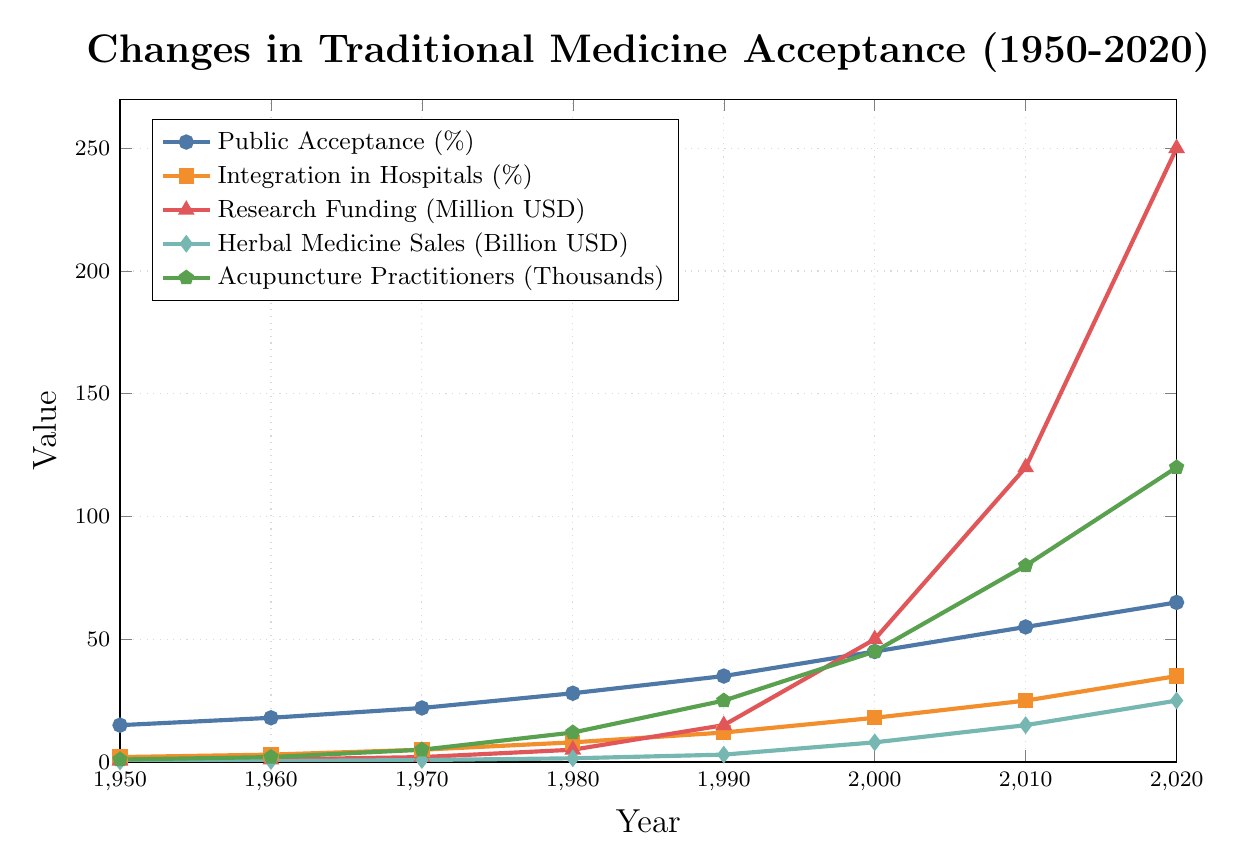Which year had the highest public acceptance of traditional medicine? Check the curve labeled "Public Acceptance (%)" and find the highest point. It's at 2020.
Answer: 2020 Has research funding increased more rapidly after 2000 compared to before 2000? Compare the slope of the "Research Funding (Million USD)" line before and after 2000. The slope is steeper after 2000.
Answer: Yes What's the difference in herbal medicine sales between 1980 and 2020? Locate the values for "Herbal Medicine Sales" at 1980 and 2020. They are 1.5 and 25, respectively. Calculate the difference: 25 - 1.5 = 23.5.
Answer: 23.5 billion USD How does the public acceptance in 2020 compare to that in 1950? Observe the "Public Acceptance (%)" values for 1950 and 2020. They are 15% in 1950 and 65% in 2020.
Answer: It increased by 50% What's the ratio of acupuncture practitioners in 2020 to those in 1950? Check the "Acupuncture Practitioners (Thousands)" at 1950 and 2020. They are 1 and 120, respectively. Calculate the ratio: 120 / 1 = 120.
Answer: 120 Which year saw the highest integration in hospitals? Look at the "Integration in Hospitals (%)" and find the year with the maximum value. It is at 2020 with 35%.
Answer: 2020 What is the average public acceptance of traditional medicine over the decades? Sum the "Public Acceptance (%)" values (15, 18, 22, 28, 35, 45, 55, 65) and divide by the number of data points (8). (15+18+22+28+35+45+55+65) / 8 = 35.375%.
Answer: 35.375% In which decade was there the largest increase in research funding? Check the "Research Funding (Million USD)" values for each decade and find the largest difference. Largest increase is between 2000 and 2010 (120 - 50 = 70).
Answer: 2000s Did the number of acupuncture practitioners grow more between 1990 and 2000 or between 2000 and 2010? Compare growth rates: 2000 vs 1990 (45 - 25 = 20) and 2010 vs 2000 (80 - 45 = 35). The increase was larger between 2000 and 2010.
Answer: 2000 to 2010 Is there a stronger correlation between public acceptance and integration in hospitals or between herbal medicine sales and public acceptance? By visually comparing the trends, "Public Acceptance (%)" and "Integration in Hospitals (%)" both steadily increase, suggesting a strong correlation, whereas "Herbal Medicine Sales" and "Public Acceptance (%)" also both steadily rise but with varying slope rates.
Answer: Public acceptance and integration in hospitals 